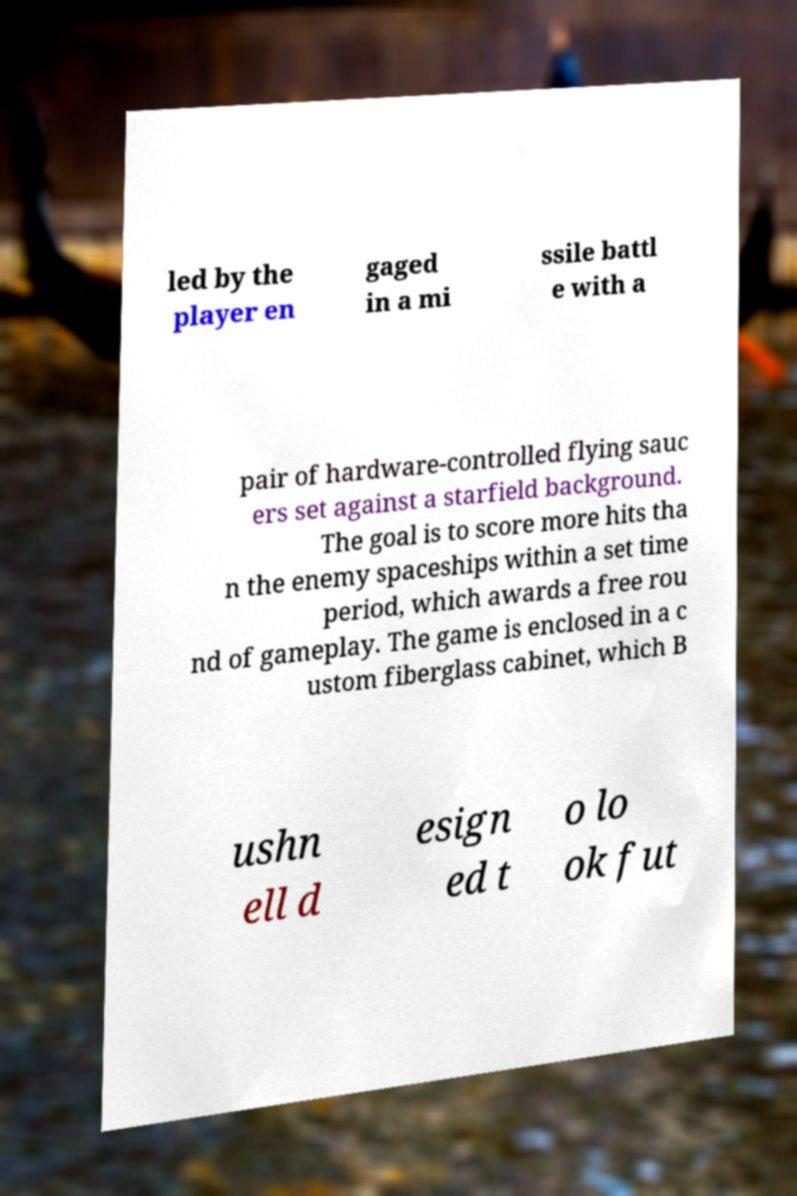There's text embedded in this image that I need extracted. Can you transcribe it verbatim? led by the player en gaged in a mi ssile battl e with a pair of hardware-controlled flying sauc ers set against a starfield background. The goal is to score more hits tha n the enemy spaceships within a set time period, which awards a free rou nd of gameplay. The game is enclosed in a c ustom fiberglass cabinet, which B ushn ell d esign ed t o lo ok fut 